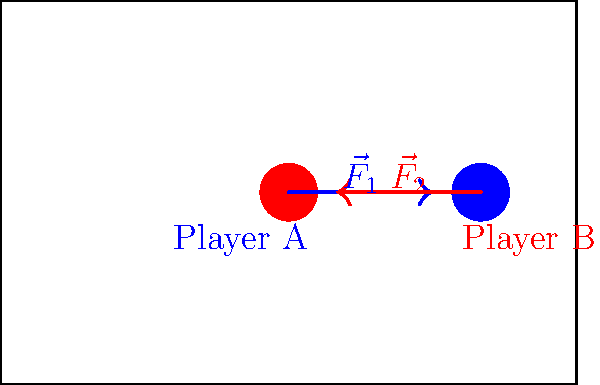During a crucial play, Player A (mass 90 kg) tackles Player B (mass 80 kg) with a force of 800 N. Player B simultaneously pushes back with a force of 600 N. Assuming both players were initially at rest, calculate the acceleration of Player B immediately after the collision. Use the vector diagram to visualize the forces acting on the players. Let's approach this step-by-step:

1) First, we need to identify the net force acting on Player B. 
   Player A exerts 800 N to the right (positive direction).
   Player B exerts 600 N to the left (negative direction).
   Net force = 800 N - 600 N = 200 N to the right

2) We can use Newton's Second Law of Motion: $F = ma$

3) Rearranging the formula to solve for acceleration: $a = \frac{F}{m}$

4) We know:
   Net force (F) = 200 N
   Mass of Player B (m) = 80 kg

5) Plugging in the values:
   $a = \frac{200 \text{ N}}{80 \text{ kg}} = 2.5 \text{ m/s}^2$

6) The positive value indicates that the acceleration is in the same direction as the net force, which is to the right.

Therefore, Player B accelerates at 2.5 m/s² to the right immediately after the collision.
Answer: $2.5 \text{ m/s}^2$ to the right 